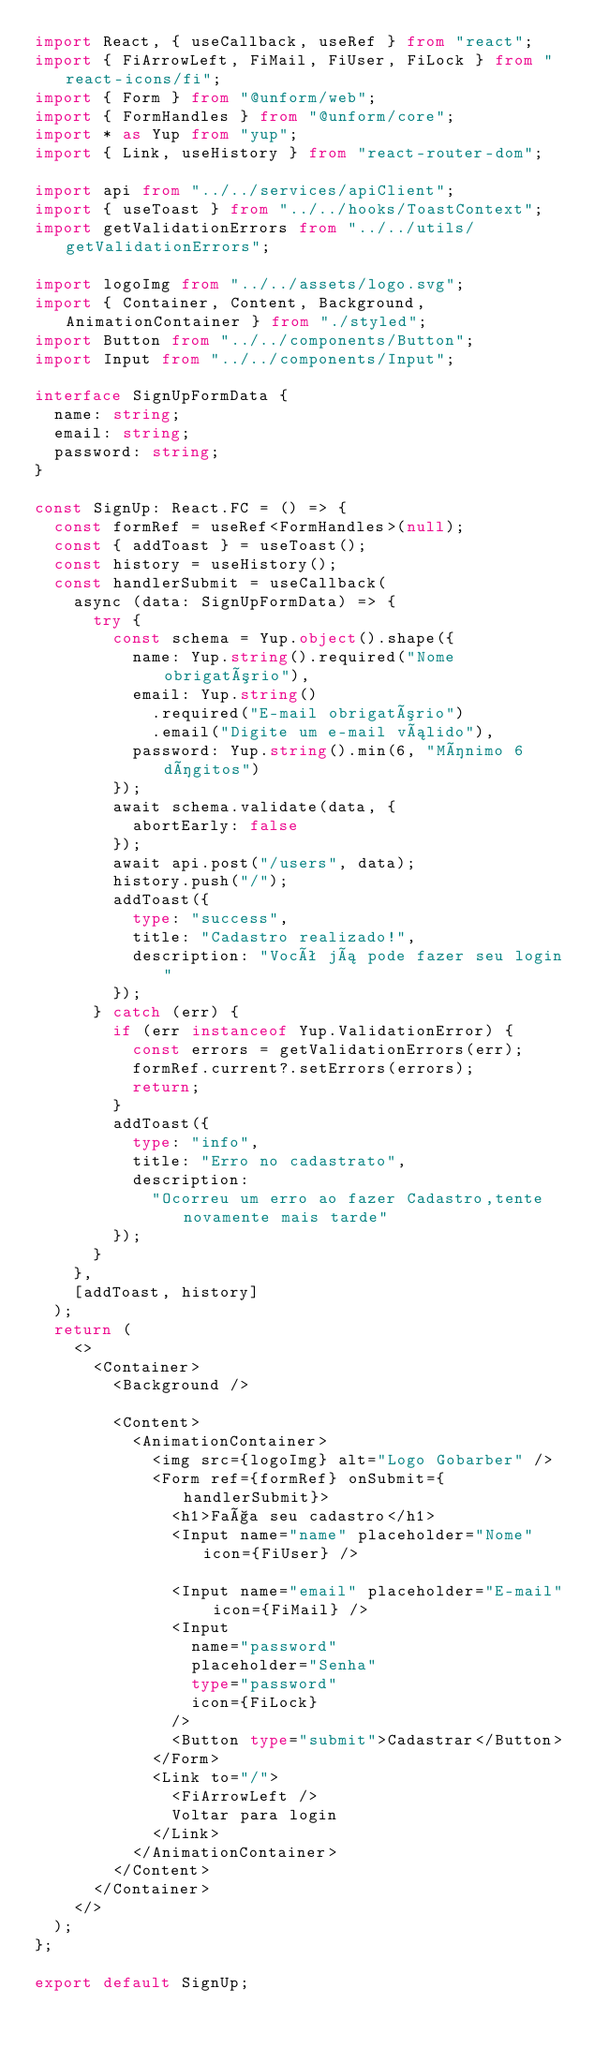<code> <loc_0><loc_0><loc_500><loc_500><_TypeScript_>import React, { useCallback, useRef } from "react";
import { FiArrowLeft, FiMail, FiUser, FiLock } from "react-icons/fi";
import { Form } from "@unform/web";
import { FormHandles } from "@unform/core";
import * as Yup from "yup";
import { Link, useHistory } from "react-router-dom";

import api from "../../services/apiClient";
import { useToast } from "../../hooks/ToastContext";
import getValidationErrors from "../../utils/getValidationErrors";

import logoImg from "../../assets/logo.svg";
import { Container, Content, Background, AnimationContainer } from "./styled";
import Button from "../../components/Button";
import Input from "../../components/Input";

interface SignUpFormData {
  name: string;
  email: string;
  password: string;
}

const SignUp: React.FC = () => {
  const formRef = useRef<FormHandles>(null);
  const { addToast } = useToast();
  const history = useHistory();
  const handlerSubmit = useCallback(
    async (data: SignUpFormData) => {
      try {
        const schema = Yup.object().shape({
          name: Yup.string().required("Nome obrigatório"),
          email: Yup.string()
            .required("E-mail obrigatório")
            .email("Digite um e-mail válido"),
          password: Yup.string().min(6, "Mínimo 6 dígitos")
        });
        await schema.validate(data, {
          abortEarly: false
        });
        await api.post("/users", data);
        history.push("/");
        addToast({
          type: "success",
          title: "Cadastro realizado!",
          description: "Você já pode fazer seu login"
        });
      } catch (err) {
        if (err instanceof Yup.ValidationError) {
          const errors = getValidationErrors(err);
          formRef.current?.setErrors(errors);
          return;
        }
        addToast({
          type: "info",
          title: "Erro no cadastrato",
          description:
            "Ocorreu um erro ao fazer Cadastro,tente novamente mais tarde"
        });
      }
    },
    [addToast, history]
  );
  return (
    <>
      <Container>
        <Background />

        <Content>
          <AnimationContainer>
            <img src={logoImg} alt="Logo Gobarber" />
            <Form ref={formRef} onSubmit={handlerSubmit}>
              <h1>Faça seu cadastro</h1>
              <Input name="name" placeholder="Nome" icon={FiUser} />

              <Input name="email" placeholder="E-mail" icon={FiMail} />
              <Input
                name="password"
                placeholder="Senha"
                type="password"
                icon={FiLock}
              />
              <Button type="submit">Cadastrar</Button>
            </Form>
            <Link to="/">
              <FiArrowLeft />
              Voltar para login
            </Link>
          </AnimationContainer>
        </Content>
      </Container>
    </>
  );
};

export default SignUp;
</code> 